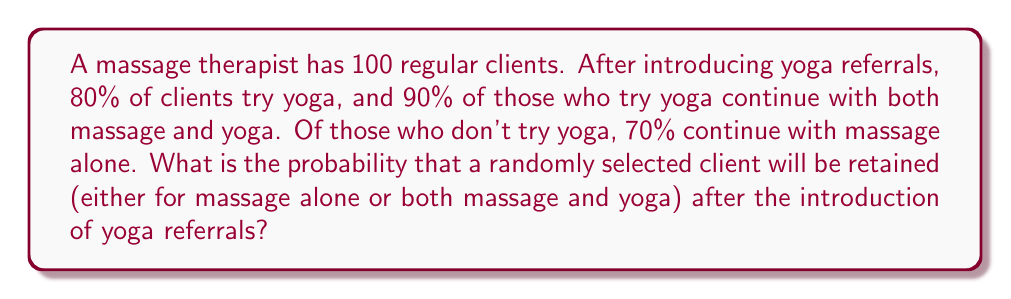Show me your answer to this math problem. Let's break this down step-by-step:

1) First, let's identify the given information:
   - Total clients: 100
   - Percentage of clients who try yoga: 80% = 0.8
   - Retention rate for clients who try yoga: 90% = 0.9
   - Retention rate for clients who don't try yoga: 70% = 0.7

2) Calculate the number of clients in each category:
   - Clients who try yoga: $100 \times 0.8 = 80$
   - Clients who don't try yoga: $100 - 80 = 20$

3) Calculate the number of retained clients in each category:
   - Retained clients who tried yoga: $80 \times 0.9 = 72$
   - Retained clients who didn't try yoga: $20 \times 0.7 = 14$

4) Calculate the total number of retained clients:
   $72 + 14 = 86$

5) Calculate the probability of client retention:
   $$P(\text{retention}) = \frac{\text{Number of retained clients}}{\text{Total number of clients}} = \frac{86}{100} = 0.86$$

Therefore, the probability that a randomly selected client will be retained is 0.86 or 86%.
Answer: 0.86 